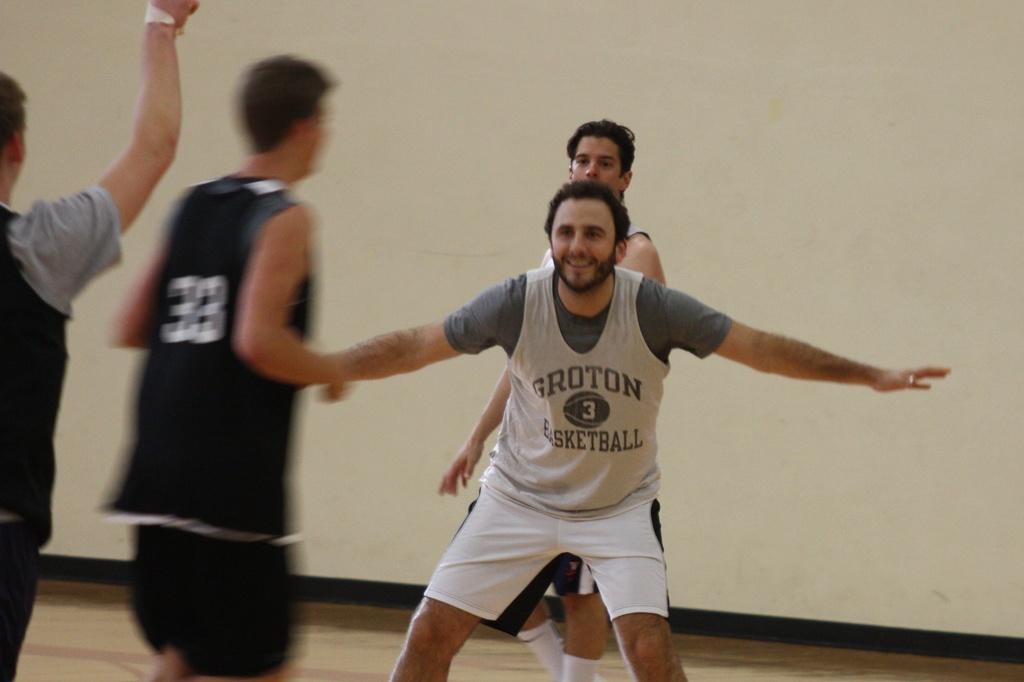What sport name is on the man's shirt?
Offer a very short reply. Basketball. What is the number of the player in the black jersey?
Your answer should be compact. 33. 